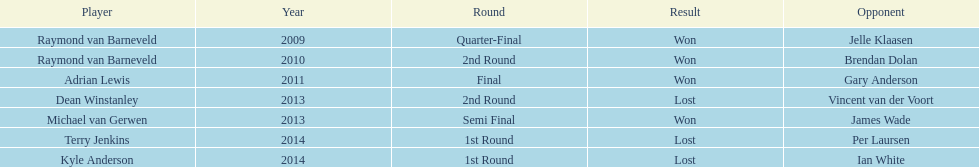Who claimed victory in the first ever world darts championship? Raymond van Barneveld. 